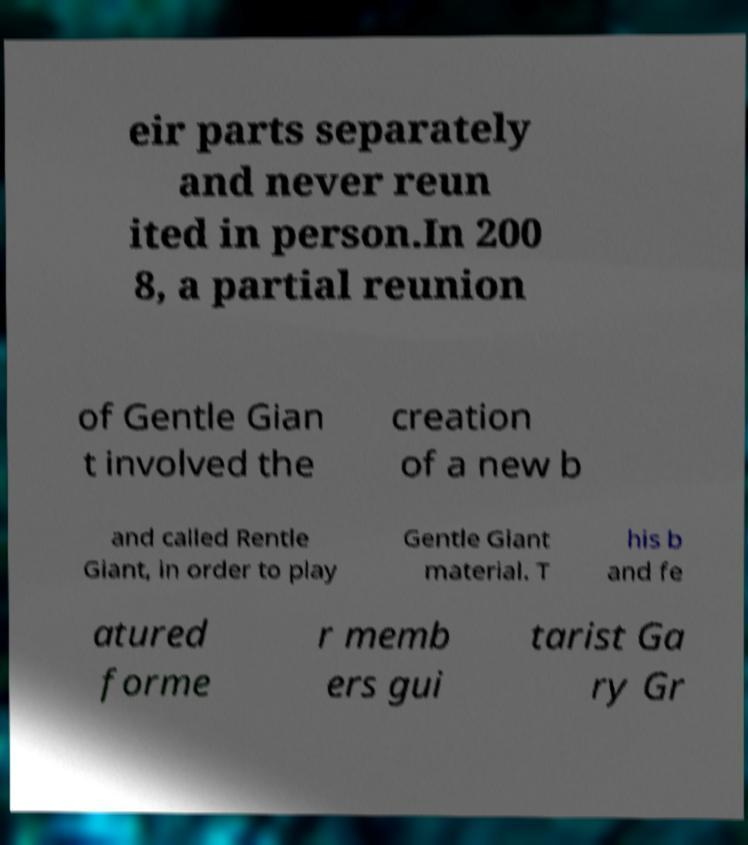Could you assist in decoding the text presented in this image and type it out clearly? eir parts separately and never reun ited in person.In 200 8, a partial reunion of Gentle Gian t involved the creation of a new b and called Rentle Giant, in order to play Gentle Giant material. T his b and fe atured forme r memb ers gui tarist Ga ry Gr 